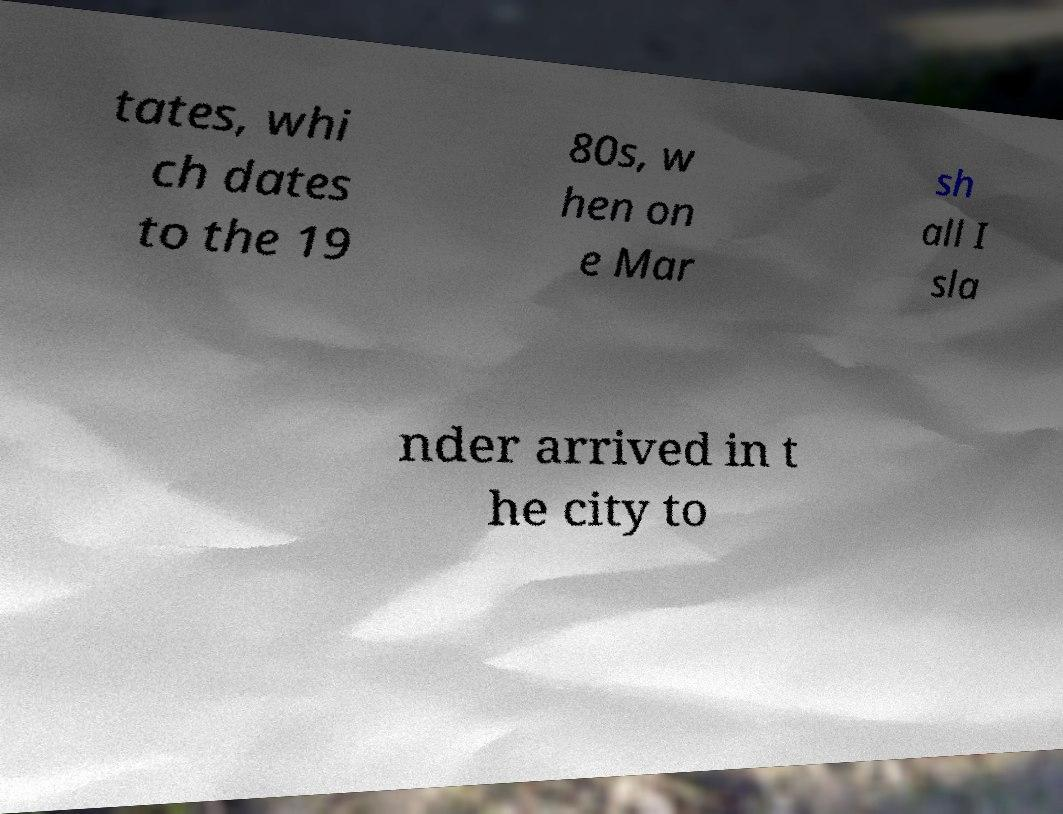For documentation purposes, I need the text within this image transcribed. Could you provide that? tates, whi ch dates to the 19 80s, w hen on e Mar sh all I sla nder arrived in t he city to 